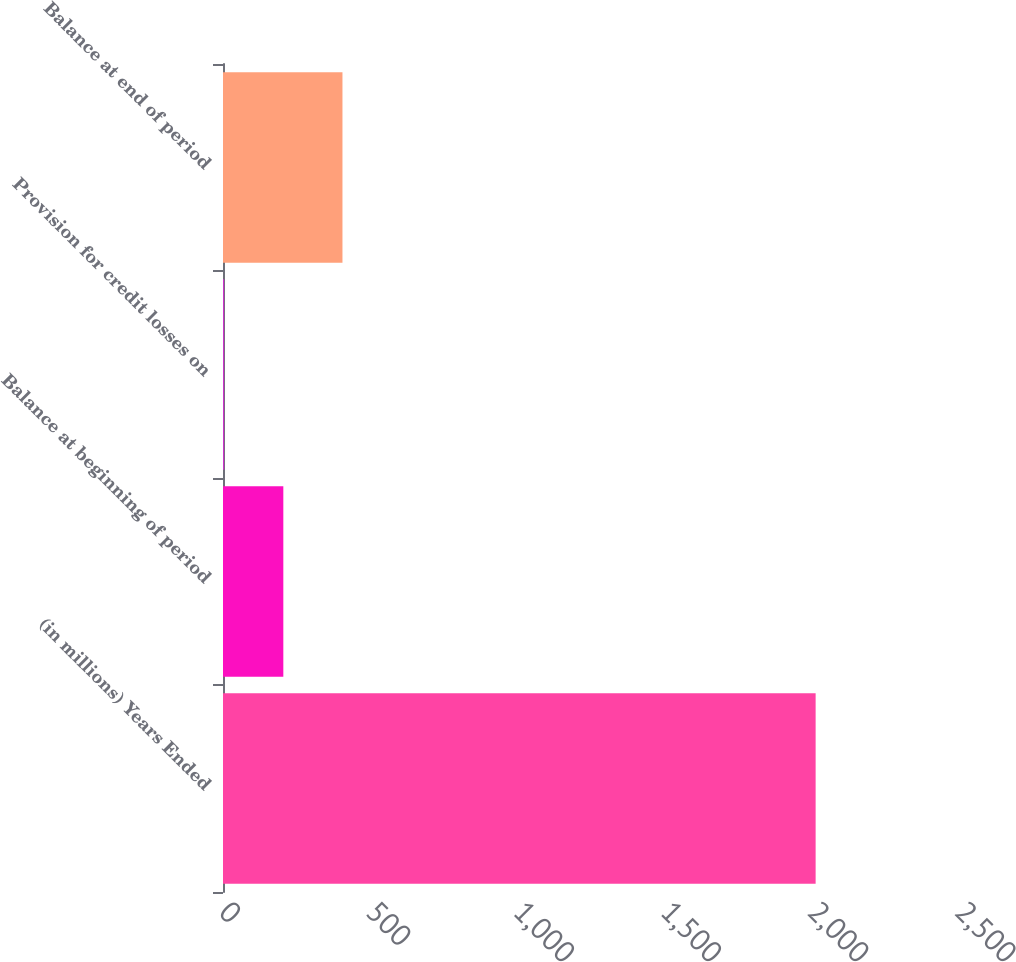<chart> <loc_0><loc_0><loc_500><loc_500><bar_chart><fcel>(in millions) Years Ended<fcel>Balance at beginning of period<fcel>Provision for credit losses on<fcel>Balance at end of period<nl><fcel>2013<fcel>204.9<fcel>4<fcel>405.8<nl></chart> 